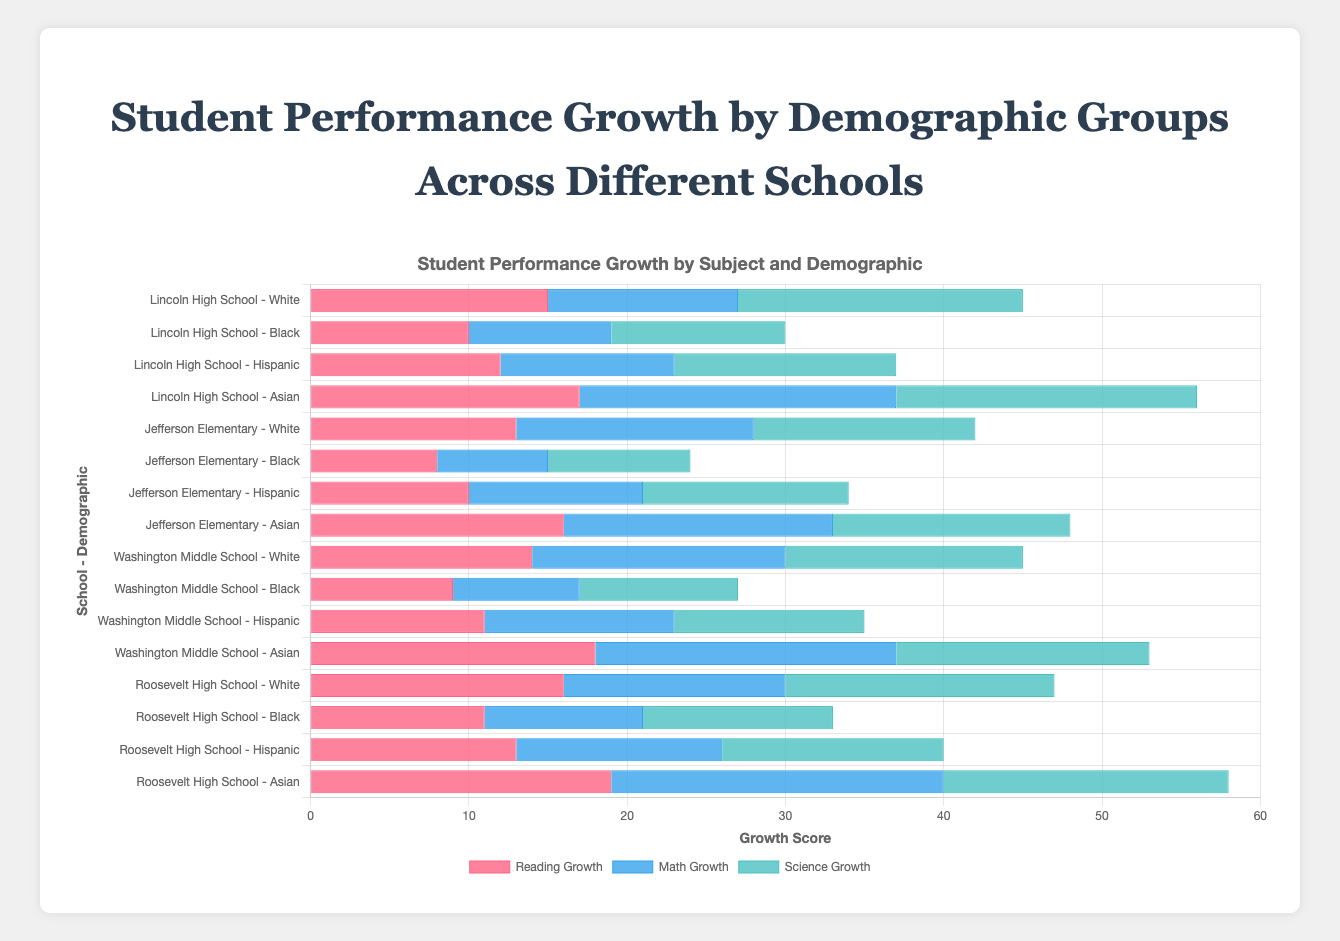Which school and demographic group has the highest reading growth? The group with the highest reading growth can be identified by finding the bar with the greatest length in the Reading Growth section. The label corresponding to the longest red bar shows "Roosevelt High School - Asian" with a value of 19.
Answer: Roosevelt High School - Asian What is the total science growth for Hispanic students across all schools? To determine the total science growth for Hispanic students, sum the science growth values for Hispanic students from all schools: Lincoln High School (14) + Jefferson Elementary (13) + Washington Middle School (12) + Roosevelt High School (14) = 53.
Answer: 53 Compare the math growth between Asian students at Lincoln High School and Washington Middle School. Which group has higher growth? The blue bar section indicates the math growth. For Lincoln High School - Asian, the math growth is 20, and for Washington Middle School - Asian, it is 19. Lincoln High School - Asian's math growth is higher.
Answer: Lincoln High School - Asian Which demographic group at Washington Middle School has the lowest reading growth? Identify the shortest red bar among the reading growth bars for Washington Middle School. The reading growth for Black students is 9, which is the lowest compared to 14 (White), 11 (Hispanic), and 18 (Asian).
Answer: Black For Jefferson Elementary, how does the combined reading and science growth for White students compare to that of Black students? Calculate the combined growth for White and Black students (ReadingGrowth + ScienceGrowth): White: 13 (Reading) + 14 (Science) = 27, Black: 8 (Reading) + 9 (Science) = 17. Thus, White students have a higher combined growth compared to Black students.
Answer: Higher for White students What is the average math growth for all students at Roosevelt High School? To find the average math growth for all students at Roosevelt High School, first sum the math growth values and then divide by the number of demographic groups: (14 + 10 + 13 + 21) / 4 = 14.5.
Answer: 14.5 Which school shows the highest overall science growth for Asian students? Compare the green bar sections (Science Growth) for Asian students across all schools. Lincoln High School (19), Jefferson Elementary (15), Washington Middle School (16), and Roosevelt High School (18). The highest is at Lincoln High School with 19.
Answer: Lincoln High School Is the math growth for Hispanic students at each elementary school higher, lower, or the same as the reading growth for the same group at the same schools? Jefferson Elementary: Math growth (11) vs Reading growth (10), lower. Washington Middle School: Math growth (12) vs Reading growth (11), higher.
Answer: Jefferson Elementary: lower, Washington Middle School: higher 